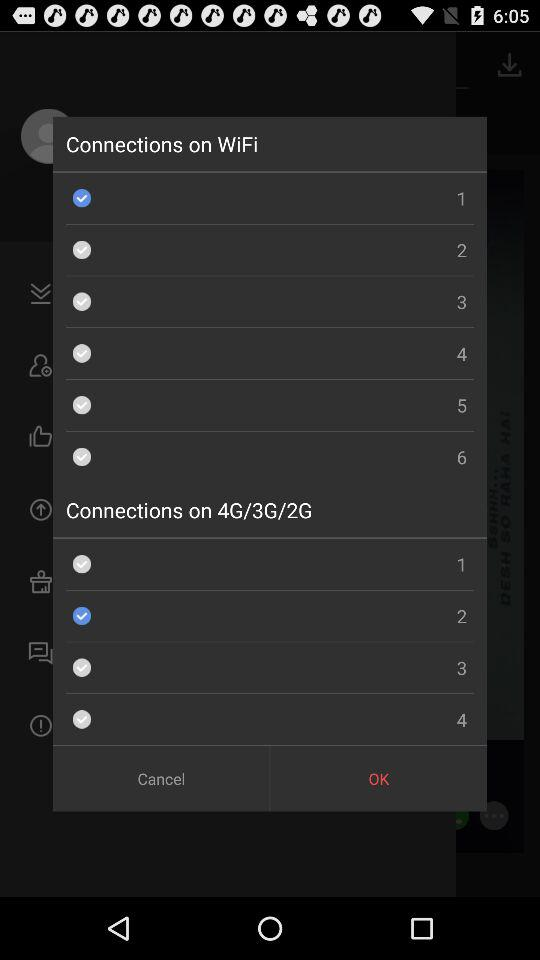How many Wi-Fi networks is the user connected to?
When the provided information is insufficient, respond with <no answer>. <no answer> 